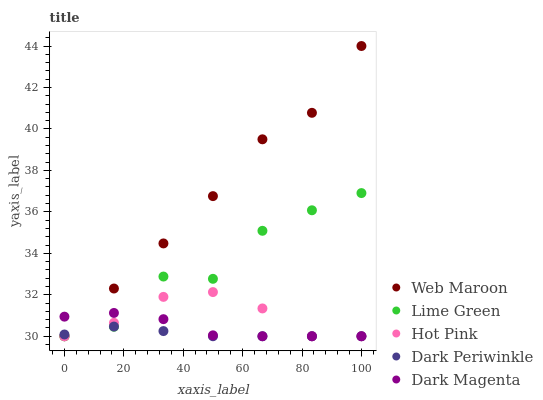Does Dark Periwinkle have the minimum area under the curve?
Answer yes or no. Yes. Does Web Maroon have the maximum area under the curve?
Answer yes or no. Yes. Does Hot Pink have the minimum area under the curve?
Answer yes or no. No. Does Hot Pink have the maximum area under the curve?
Answer yes or no. No. Is Dark Periwinkle the smoothest?
Answer yes or no. Yes. Is Lime Green the roughest?
Answer yes or no. Yes. Is Hot Pink the smoothest?
Answer yes or no. No. Is Hot Pink the roughest?
Answer yes or no. No. Does Lime Green have the lowest value?
Answer yes or no. Yes. Does Web Maroon have the highest value?
Answer yes or no. Yes. Does Hot Pink have the highest value?
Answer yes or no. No. Does Lime Green intersect Hot Pink?
Answer yes or no. Yes. Is Lime Green less than Hot Pink?
Answer yes or no. No. Is Lime Green greater than Hot Pink?
Answer yes or no. No. 